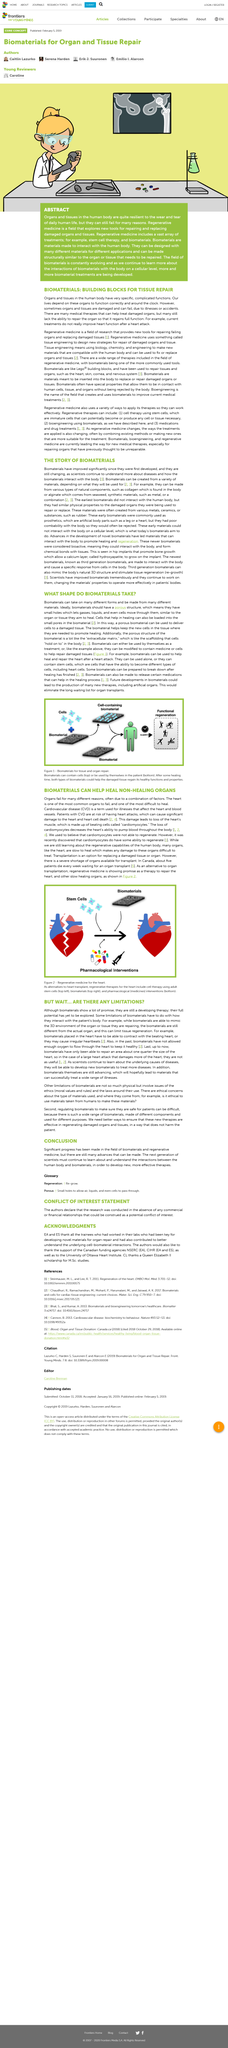Mention a couple of crucial points in this snapshot. Yes, the biomaterials depicted in Figure 1 can be used together to provide treatment. Biomaterials are used to aid healing by containing various types of cells, including stem cells, which have the potential to differentiate into various cell types and promote tissue regeneration and repair. It is possible to use multiple types of regenerative therapy at the same time, as multiple kinds can be administered simultaneously. A biomaterial with a porous structure is considered to be the ideal structure for various applications in the field of biomaterials. Regenerative medicine currently cannot restore heart function to normal after a heart attack. 